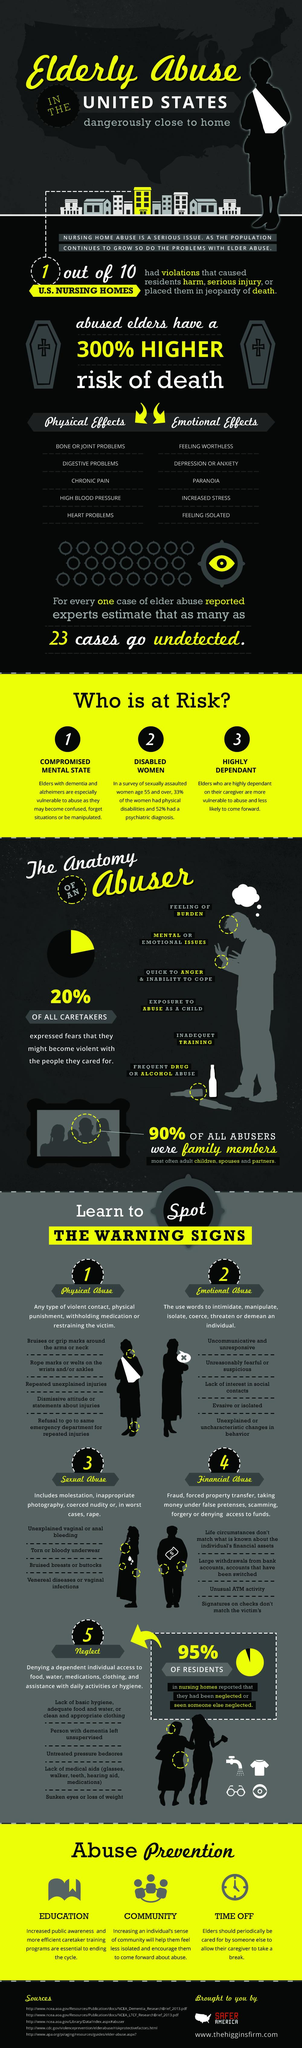Indicate a few pertinent items in this graphic. There are three ways to prevent abuse. In the United States, a study found that there was a high percentage of violations in nursing homes. Specifically, the study found that there were approximately 10% of nursing homes that were in violation of various regulations and standards. Chronic pain is a significant and concerning physical effect that can significantly impact an individual's quality of life. Ninety-five percent of respondents have reported neglect. Untreated pressure sores are a sign of neglect. 